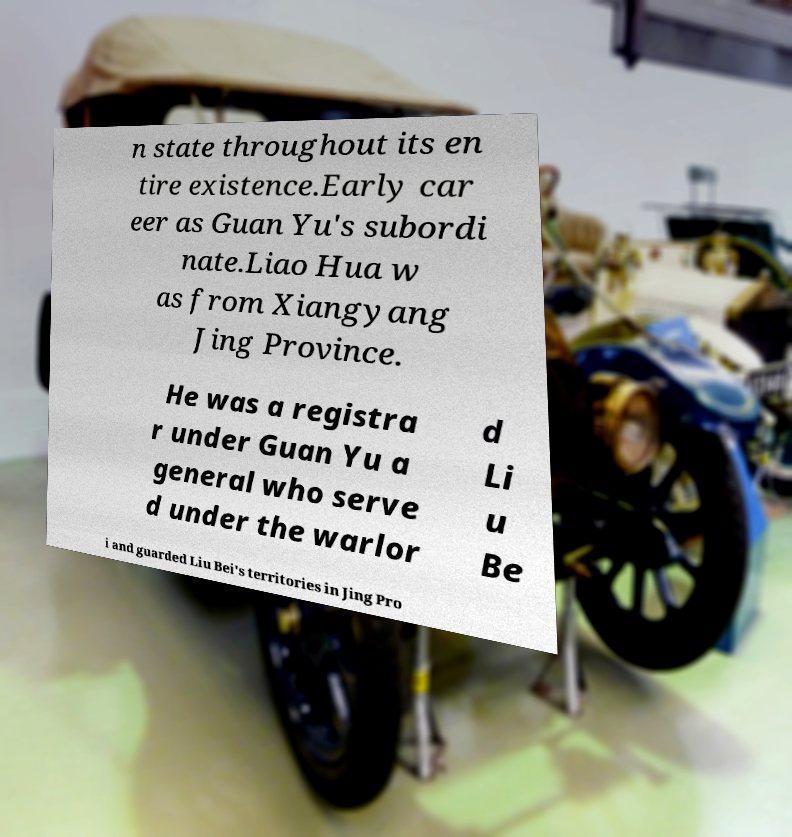Could you assist in decoding the text presented in this image and type it out clearly? n state throughout its en tire existence.Early car eer as Guan Yu's subordi nate.Liao Hua w as from Xiangyang Jing Province. He was a registra r under Guan Yu a general who serve d under the warlor d Li u Be i and guarded Liu Bei's territories in Jing Pro 